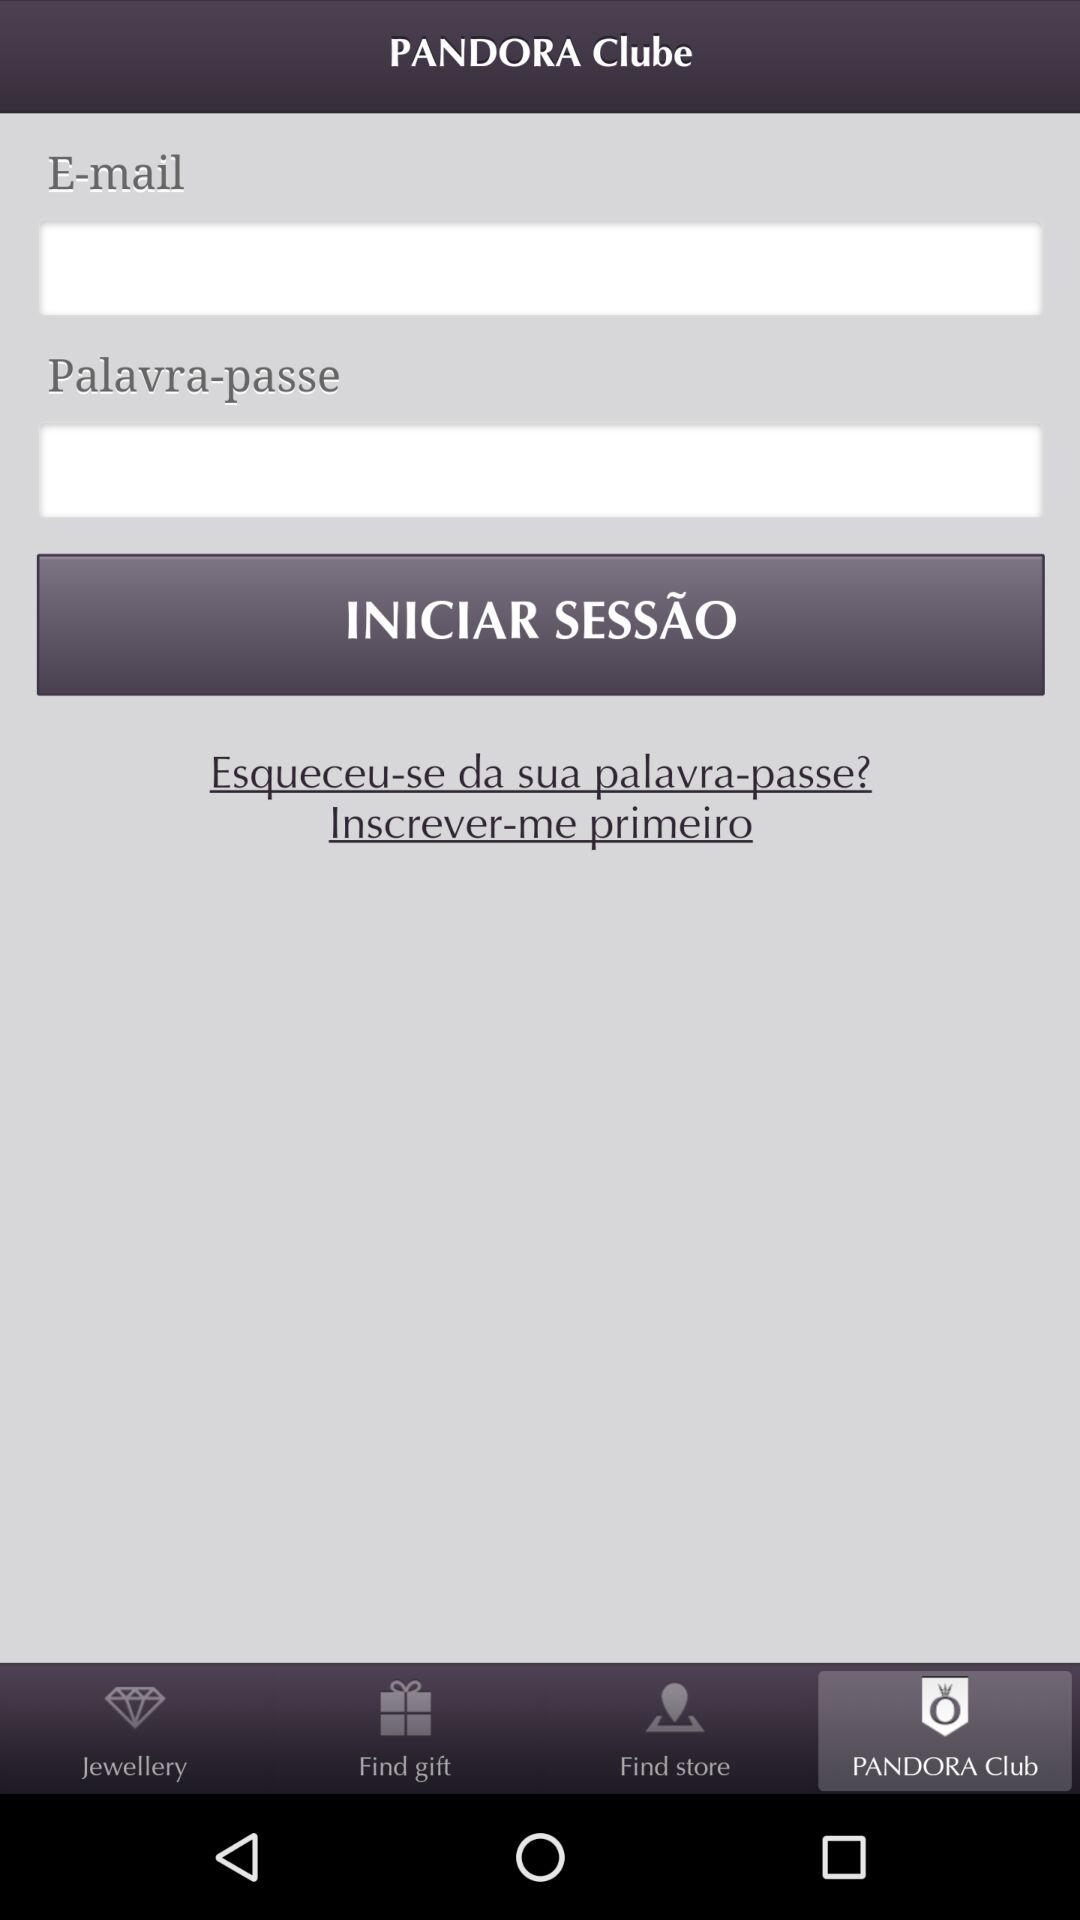Which tab is selected? The selected tab is Pandora Club. 